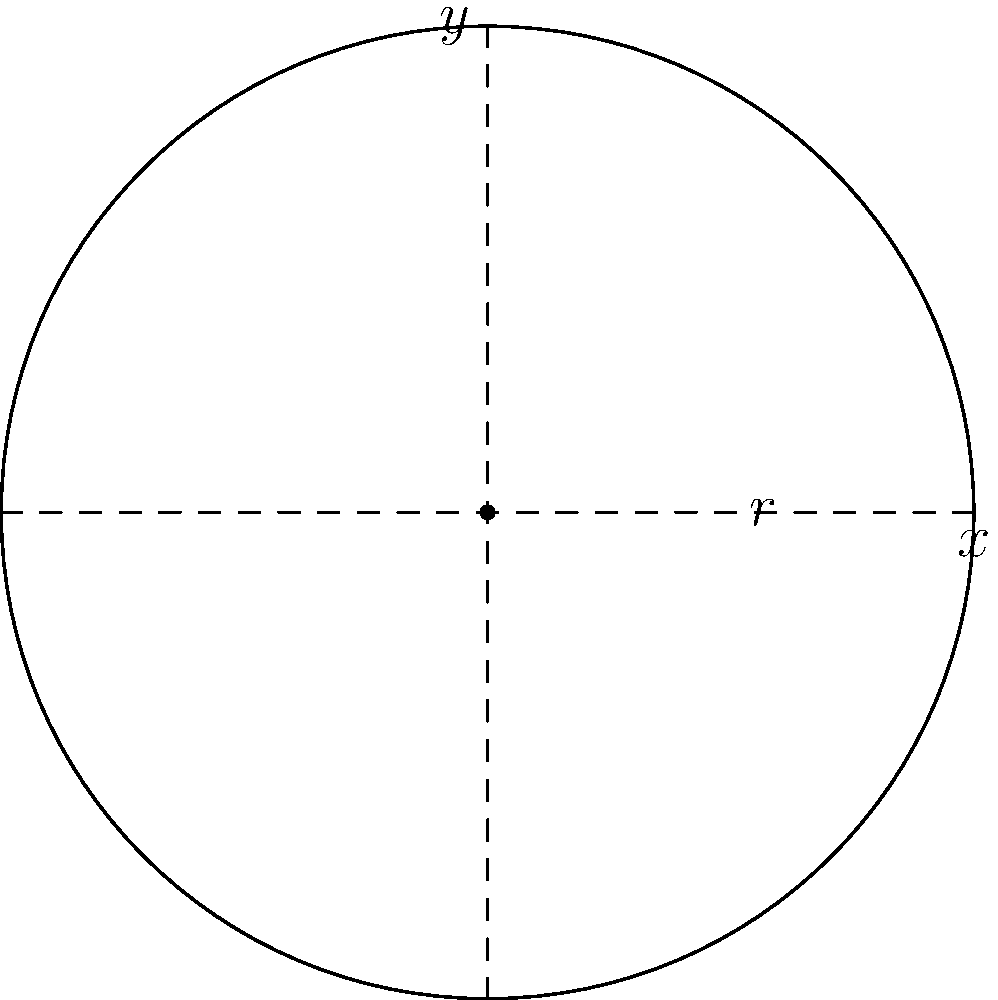As a chef specializing in Chicago-style deep-dish pizza, you want to optimize the arrangement of toppings on a circular pizza. The pizza has a radius of 12 inches, and you want to maximize the area covered by toppings while leaving a 1-inch border around the edge. What is the maximum area (in square inches) that can be covered by toppings? Let's approach this step-by-step:

1) The pizza has a radius of 12 inches, but we need to leave a 1-inch border. So, the area for toppings will have a radius of 11 inches.

2) The area of a circle is given by the formula $A = \pi r^2$, where $r$ is the radius.

3) For the entire pizza:
   $A_{total} = \pi (12)^2 = 144\pi$ square inches

4) For the area that can be covered by toppings:
   $A_{toppings} = \pi (11)^2 = 121\pi$ square inches

5) To get the exact value, we multiply by $\pi$:
   $A_{toppings} = 121\pi \approx 380.13$ square inches

Therefore, the maximum area that can be covered by toppings is approximately 380.13 square inches.
Answer: $121\pi$ square inches (or approximately 380.13 square inches) 